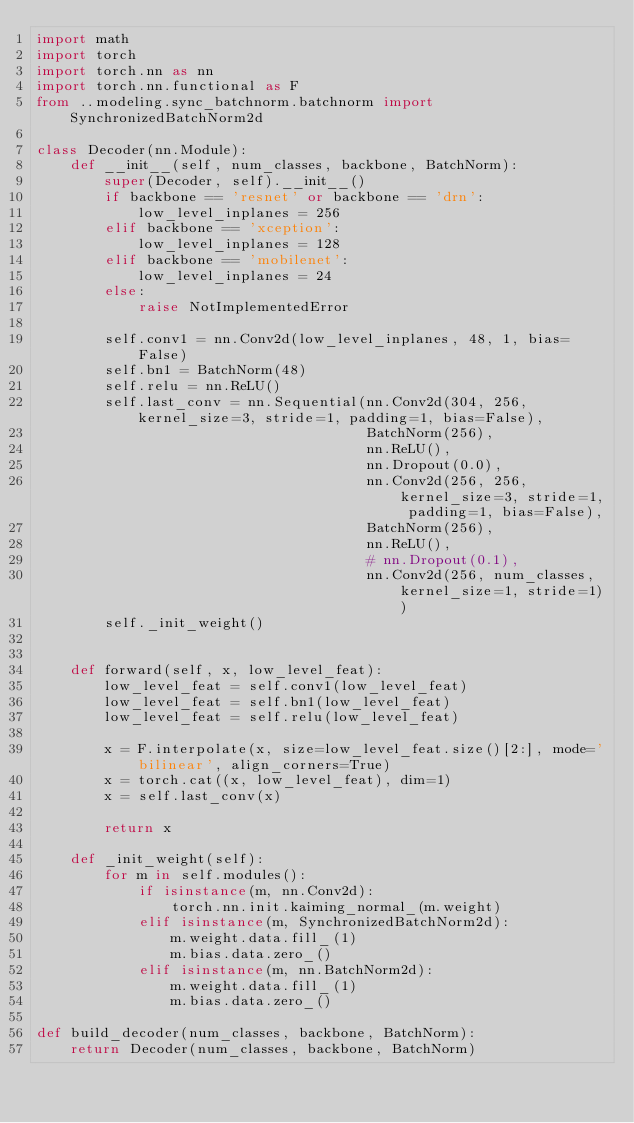Convert code to text. <code><loc_0><loc_0><loc_500><loc_500><_Python_>import math
import torch
import torch.nn as nn
import torch.nn.functional as F
from ..modeling.sync_batchnorm.batchnorm import SynchronizedBatchNorm2d

class Decoder(nn.Module):
    def __init__(self, num_classes, backbone, BatchNorm):
        super(Decoder, self).__init__()
        if backbone == 'resnet' or backbone == 'drn':
            low_level_inplanes = 256
        elif backbone == 'xception':
            low_level_inplanes = 128
        elif backbone == 'mobilenet':
            low_level_inplanes = 24
        else:
            raise NotImplementedError

        self.conv1 = nn.Conv2d(low_level_inplanes, 48, 1, bias=False)
        self.bn1 = BatchNorm(48)
        self.relu = nn.ReLU()
        self.last_conv = nn.Sequential(nn.Conv2d(304, 256, kernel_size=3, stride=1, padding=1, bias=False),
                                       BatchNorm(256),
                                       nn.ReLU(),
                                       nn.Dropout(0.0),
                                       nn.Conv2d(256, 256, kernel_size=3, stride=1, padding=1, bias=False),
                                       BatchNorm(256),
                                       nn.ReLU(),
                                       # nn.Dropout(0.1),
                                       nn.Conv2d(256, num_classes, kernel_size=1, stride=1))
        self._init_weight()


    def forward(self, x, low_level_feat):
        low_level_feat = self.conv1(low_level_feat)
        low_level_feat = self.bn1(low_level_feat)
        low_level_feat = self.relu(low_level_feat)

        x = F.interpolate(x, size=low_level_feat.size()[2:], mode='bilinear', align_corners=True)
        x = torch.cat((x, low_level_feat), dim=1)
        x = self.last_conv(x)

        return x

    def _init_weight(self):
        for m in self.modules():
            if isinstance(m, nn.Conv2d):
                torch.nn.init.kaiming_normal_(m.weight)
            elif isinstance(m, SynchronizedBatchNorm2d):
                m.weight.data.fill_(1)
                m.bias.data.zero_()
            elif isinstance(m, nn.BatchNorm2d):
                m.weight.data.fill_(1)
                m.bias.data.zero_()

def build_decoder(num_classes, backbone, BatchNorm):
    return Decoder(num_classes, backbone, BatchNorm)
</code> 